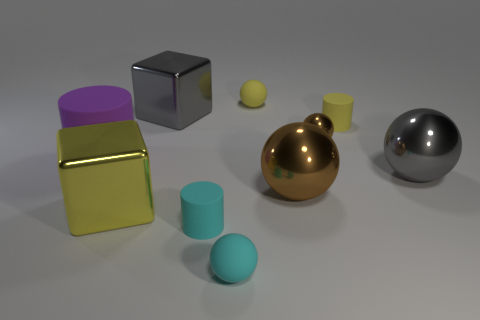Subtract all gray balls. How many balls are left? 4 Subtract all small metallic spheres. How many spheres are left? 4 Subtract all purple cubes. Subtract all cyan spheres. How many cubes are left? 2 Subtract all blocks. How many objects are left? 8 Add 7 gray shiny spheres. How many gray shiny spheres exist? 8 Subtract 0 blue cylinders. How many objects are left? 10 Subtract all tiny cyan balls. Subtract all tiny matte cylinders. How many objects are left? 7 Add 6 yellow rubber spheres. How many yellow rubber spheres are left? 7 